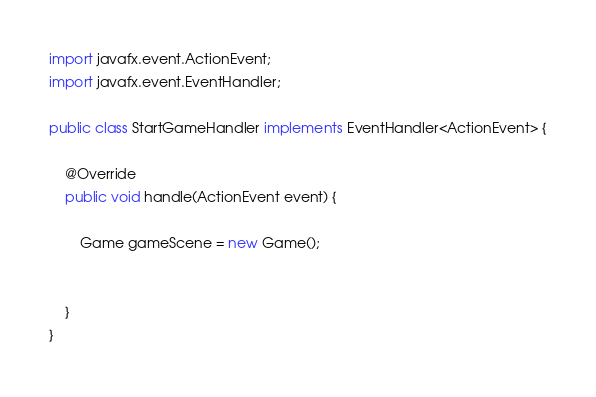<code> <loc_0><loc_0><loc_500><loc_500><_Java_>import javafx.event.ActionEvent;
import javafx.event.EventHandler;

public class StartGameHandler implements EventHandler<ActionEvent> {

	@Override
	public void handle(ActionEvent event) {

		Game gameScene = new Game();
		

	}
}</code> 